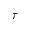<formula> <loc_0><loc_0><loc_500><loc_500>\tau</formula> 